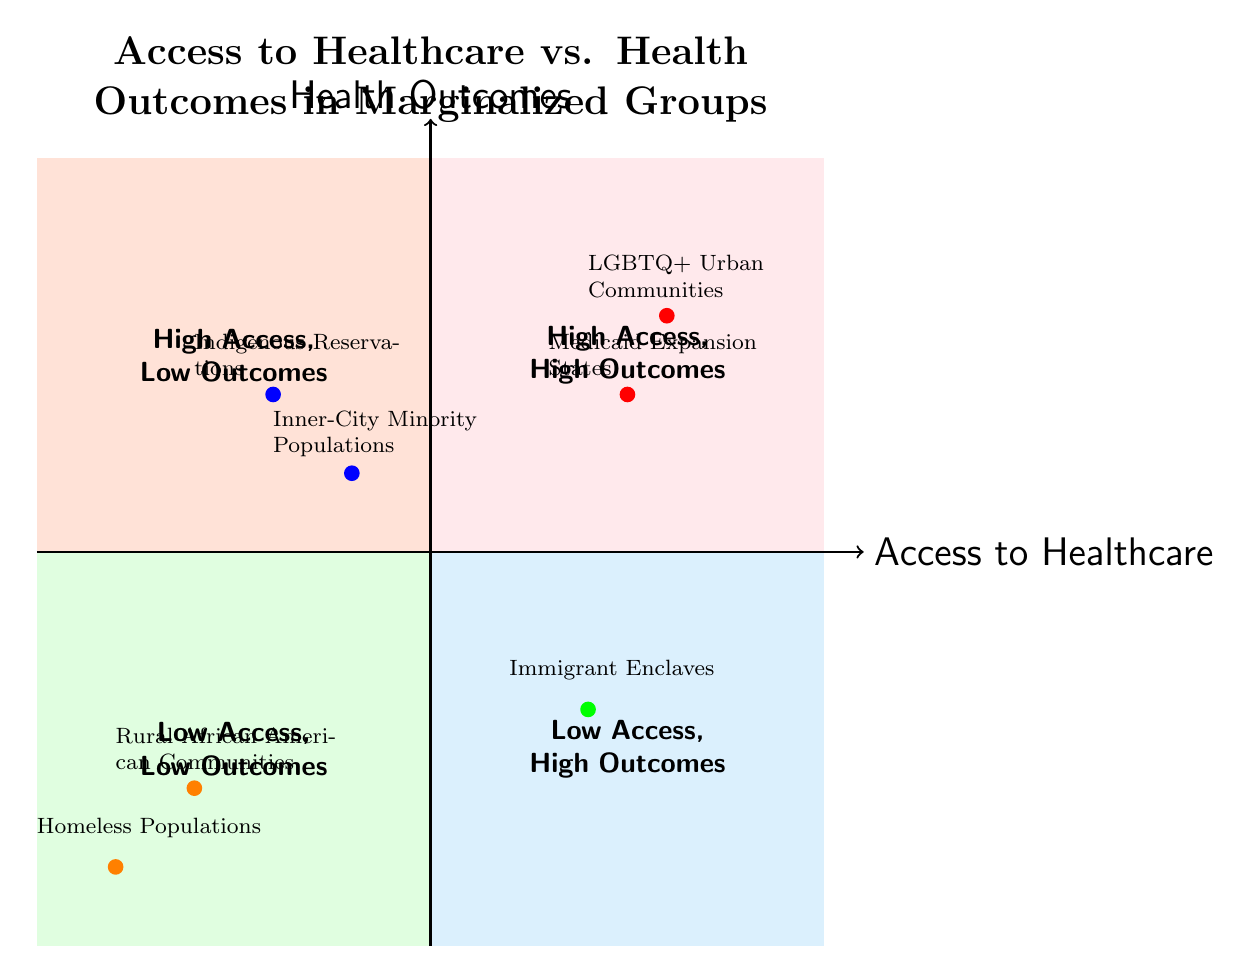What communities are in the High Access, High Outcomes quadrant? The High Access, High Outcomes quadrant contains two communities: LGBTQ+ Urban Communities and Medicaid Expansion States. Both of these communities are located in the top right quadrant, signifying high access to healthcare services and positive health outcomes.
Answer: LGBTQ+ Urban Communities, Medicaid Expansion States How many communities are in the Low Access, Low Outcomes quadrant? In the Low Access, Low Outcomes quadrant, there are two communities: Rural African American Communities and Homeless Populations. This is identified by looking at the bottom left quadrant where these two communities are plotted.
Answer: 2 What health challenges are faced by Indigenous Reservations? Indigenous Reservations are observed in the High Access, Low Outcomes quadrant, where despite having access to healthcare through federal programs, the community faces high rates of diabetes and mental health challenges, indicated as outcomes factors for this community.
Answer: High rates of diabetes, mental health challenges Which quadrant contains Immigrant Enclaves? Immigrant Enclaves are found in the Low Access, High Outcomes quadrant. This position reflects that despite limited official healthcare access, the community achieves positive health outcomes through strong social networks and community-led health education, as indicated in the quadrant description.
Answer: Low Access, High Outcomes What is the primary access factor for Rural African American Communities? The primary access factor for Rural African American Communities, located in the Low Access, Low Outcomes quadrant, is the scarcity of healthcare providers coupled with transportation barriers, as outlined in the description provided for this community's access factors.
Answer: Scarcity of healthcare providers, transportation barriers Identify the quadrant where Inner-City Minority Populations are located. Inner-City Minority Populations are situated in the High Access, Low Outcomes quadrant which indicates that although there are numerous healthcare facilities available to them, they still face health challenges such as high prevalence of hypertension and disparities in cancer treatment.
Answer: High Access, Low Outcomes How does social structure impact health outcomes in Immigrant Enclaves? In the Low Access, High Outcomes quadrant, Immigrant Enclaves have limited official healthcare access but benefit from strong social networks and community-led health education, contributing to better health outcomes despite the barriers. Thus, the social structure plays a crucial role in offsetting the lack of access.
Answer: Strong social networks, community-led health education What health outcomes do Homeless Populations face? Homeless Populations, placed in the Low Access, Low Outcomes quadrant, experience high rates of untreated mental illness and infectious diseases, highlighting the severe health consequences of limited access to healthcare and living conditions.
Answer: High rates of untreated mental illness, infectious diseases 